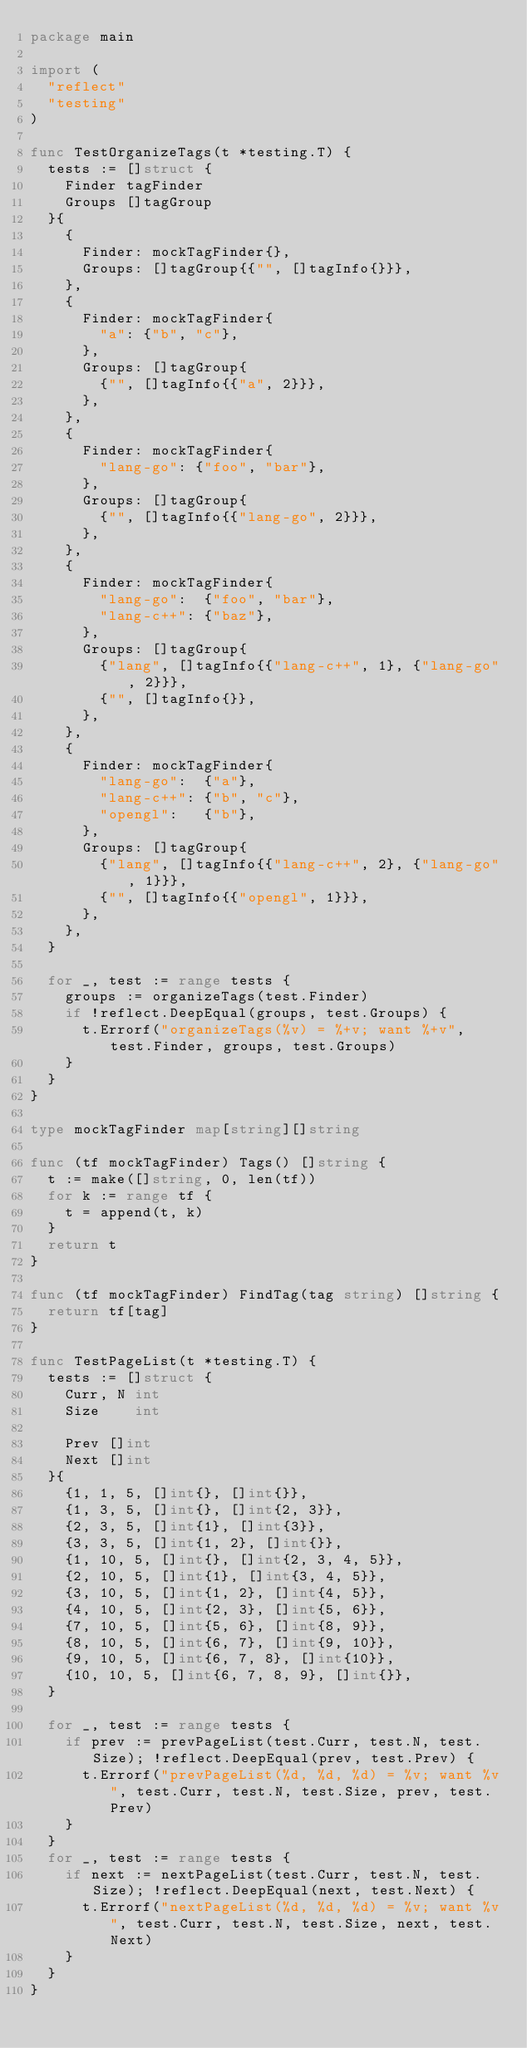Convert code to text. <code><loc_0><loc_0><loc_500><loc_500><_Go_>package main

import (
	"reflect"
	"testing"
)

func TestOrganizeTags(t *testing.T) {
	tests := []struct {
		Finder tagFinder
		Groups []tagGroup
	}{
		{
			Finder: mockTagFinder{},
			Groups: []tagGroup{{"", []tagInfo{}}},
		},
		{
			Finder: mockTagFinder{
				"a": {"b", "c"},
			},
			Groups: []tagGroup{
				{"", []tagInfo{{"a", 2}}},
			},
		},
		{
			Finder: mockTagFinder{
				"lang-go": {"foo", "bar"},
			},
			Groups: []tagGroup{
				{"", []tagInfo{{"lang-go", 2}}},
			},
		},
		{
			Finder: mockTagFinder{
				"lang-go":  {"foo", "bar"},
				"lang-c++": {"baz"},
			},
			Groups: []tagGroup{
				{"lang", []tagInfo{{"lang-c++", 1}, {"lang-go", 2}}},
				{"", []tagInfo{}},
			},
		},
		{
			Finder: mockTagFinder{
				"lang-go":  {"a"},
				"lang-c++": {"b", "c"},
				"opengl":   {"b"},
			},
			Groups: []tagGroup{
				{"lang", []tagInfo{{"lang-c++", 2}, {"lang-go", 1}}},
				{"", []tagInfo{{"opengl", 1}}},
			},
		},
	}

	for _, test := range tests {
		groups := organizeTags(test.Finder)
		if !reflect.DeepEqual(groups, test.Groups) {
			t.Errorf("organizeTags(%v) = %+v; want %+v", test.Finder, groups, test.Groups)
		}
	}
}

type mockTagFinder map[string][]string

func (tf mockTagFinder) Tags() []string {
	t := make([]string, 0, len(tf))
	for k := range tf {
		t = append(t, k)
	}
	return t
}

func (tf mockTagFinder) FindTag(tag string) []string {
	return tf[tag]
}

func TestPageList(t *testing.T) {
	tests := []struct {
		Curr, N int
		Size    int

		Prev []int
		Next []int
	}{
		{1, 1, 5, []int{}, []int{}},
		{1, 3, 5, []int{}, []int{2, 3}},
		{2, 3, 5, []int{1}, []int{3}},
		{3, 3, 5, []int{1, 2}, []int{}},
		{1, 10, 5, []int{}, []int{2, 3, 4, 5}},
		{2, 10, 5, []int{1}, []int{3, 4, 5}},
		{3, 10, 5, []int{1, 2}, []int{4, 5}},
		{4, 10, 5, []int{2, 3}, []int{5, 6}},
		{7, 10, 5, []int{5, 6}, []int{8, 9}},
		{8, 10, 5, []int{6, 7}, []int{9, 10}},
		{9, 10, 5, []int{6, 7, 8}, []int{10}},
		{10, 10, 5, []int{6, 7, 8, 9}, []int{}},
	}

	for _, test := range tests {
		if prev := prevPageList(test.Curr, test.N, test.Size); !reflect.DeepEqual(prev, test.Prev) {
			t.Errorf("prevPageList(%d, %d, %d) = %v; want %v", test.Curr, test.N, test.Size, prev, test.Prev)
		}
	}
	for _, test := range tests {
		if next := nextPageList(test.Curr, test.N, test.Size); !reflect.DeepEqual(next, test.Next) {
			t.Errorf("nextPageList(%d, %d, %d) = %v; want %v", test.Curr, test.N, test.Size, next, test.Next)
		}
	}
}
</code> 